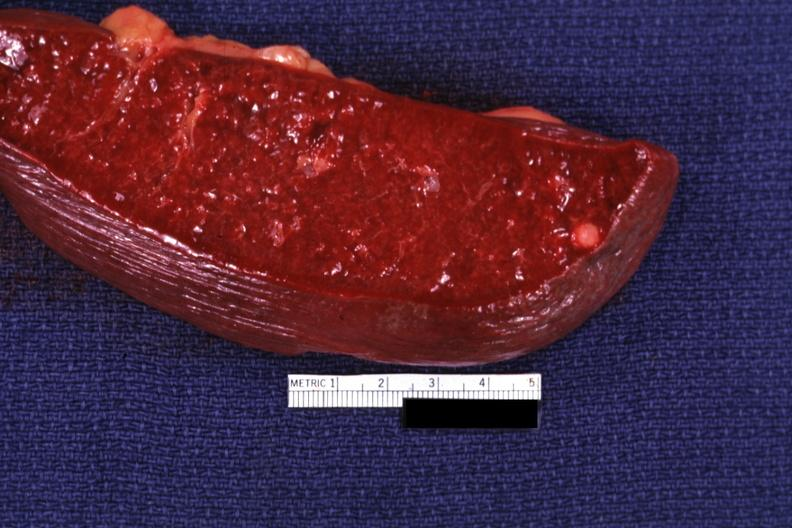s serous cyst present?
Answer the question using a single word or phrase. No 